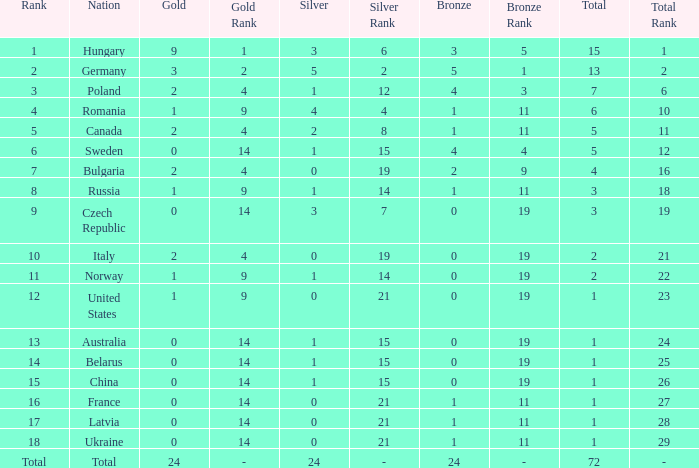What average total has 0 as the gold, with 6 as the rank? 5.0. 